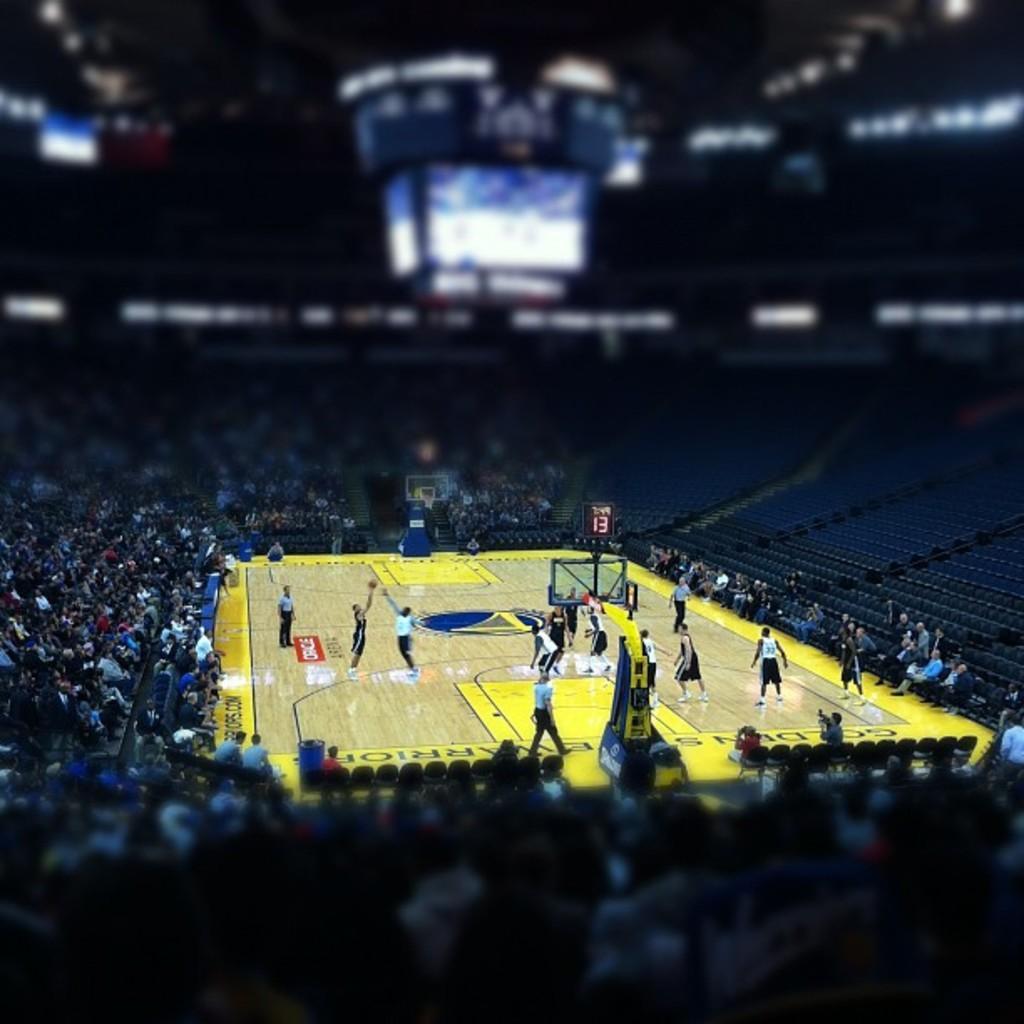In one or two sentences, can you explain what this image depicts? In this picture we can see some people are playing in a ground, around we can see so many people sitting on the staircases and watching the match. 